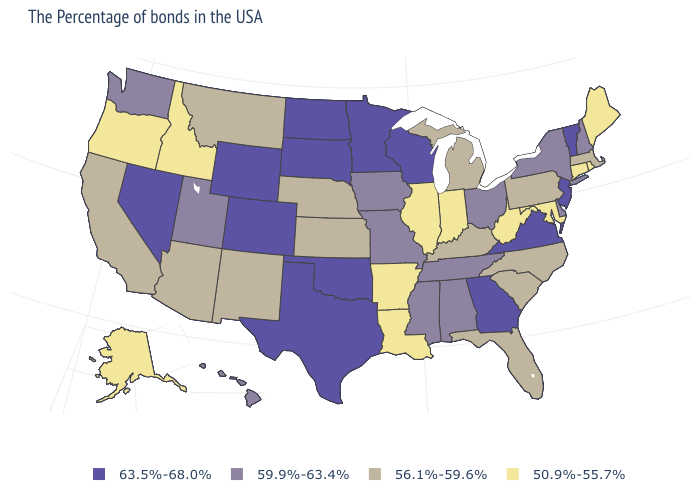Does the first symbol in the legend represent the smallest category?
Answer briefly. No. What is the lowest value in the USA?
Quick response, please. 50.9%-55.7%. Name the states that have a value in the range 56.1%-59.6%?
Be succinct. Massachusetts, Pennsylvania, North Carolina, South Carolina, Florida, Michigan, Kentucky, Kansas, Nebraska, New Mexico, Montana, Arizona, California. Among the states that border Rhode Island , which have the highest value?
Write a very short answer. Massachusetts. What is the highest value in the USA?
Short answer required. 63.5%-68.0%. Which states hav the highest value in the MidWest?
Be succinct. Wisconsin, Minnesota, South Dakota, North Dakota. Name the states that have a value in the range 56.1%-59.6%?
Short answer required. Massachusetts, Pennsylvania, North Carolina, South Carolina, Florida, Michigan, Kentucky, Kansas, Nebraska, New Mexico, Montana, Arizona, California. Does Indiana have the lowest value in the USA?
Answer briefly. Yes. What is the value of North Dakota?
Be succinct. 63.5%-68.0%. Does Mississippi have the lowest value in the South?
Be succinct. No. Name the states that have a value in the range 56.1%-59.6%?
Keep it brief. Massachusetts, Pennsylvania, North Carolina, South Carolina, Florida, Michigan, Kentucky, Kansas, Nebraska, New Mexico, Montana, Arizona, California. Which states hav the highest value in the MidWest?
Be succinct. Wisconsin, Minnesota, South Dakota, North Dakota. Among the states that border Washington , which have the lowest value?
Short answer required. Idaho, Oregon. What is the value of Utah?
Be succinct. 59.9%-63.4%. Name the states that have a value in the range 50.9%-55.7%?
Give a very brief answer. Maine, Rhode Island, Connecticut, Maryland, West Virginia, Indiana, Illinois, Louisiana, Arkansas, Idaho, Oregon, Alaska. 